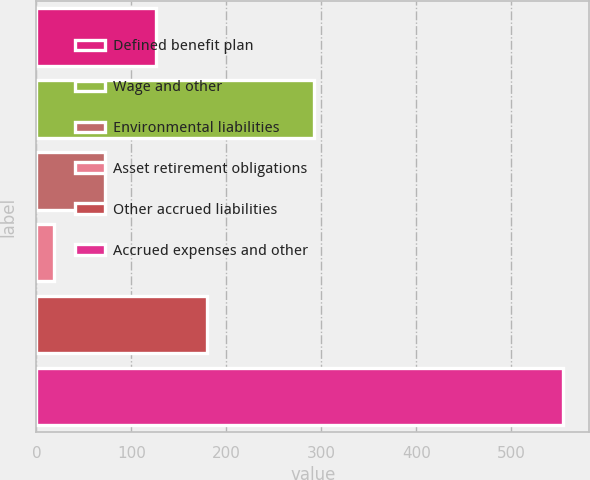Convert chart. <chart><loc_0><loc_0><loc_500><loc_500><bar_chart><fcel>Defined benefit plan<fcel>Wage and other<fcel>Environmental liabilities<fcel>Asset retirement obligations<fcel>Other accrued liabilities<fcel>Accrued expenses and other<nl><fcel>126<fcel>292<fcel>72.5<fcel>19<fcel>179.5<fcel>554<nl></chart> 